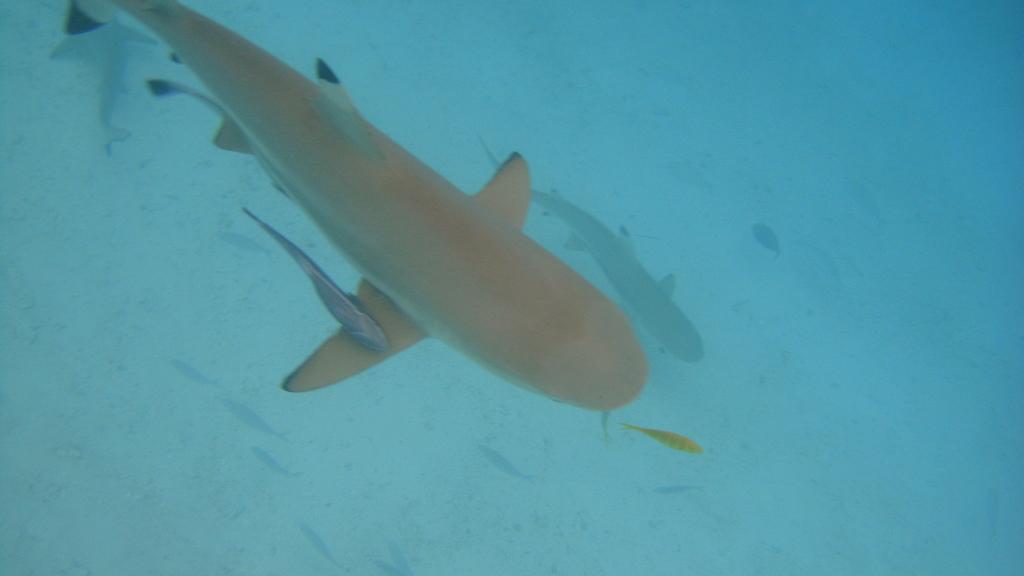Describe this image in one or two sentences. In this picture I can see fishes in the water. 